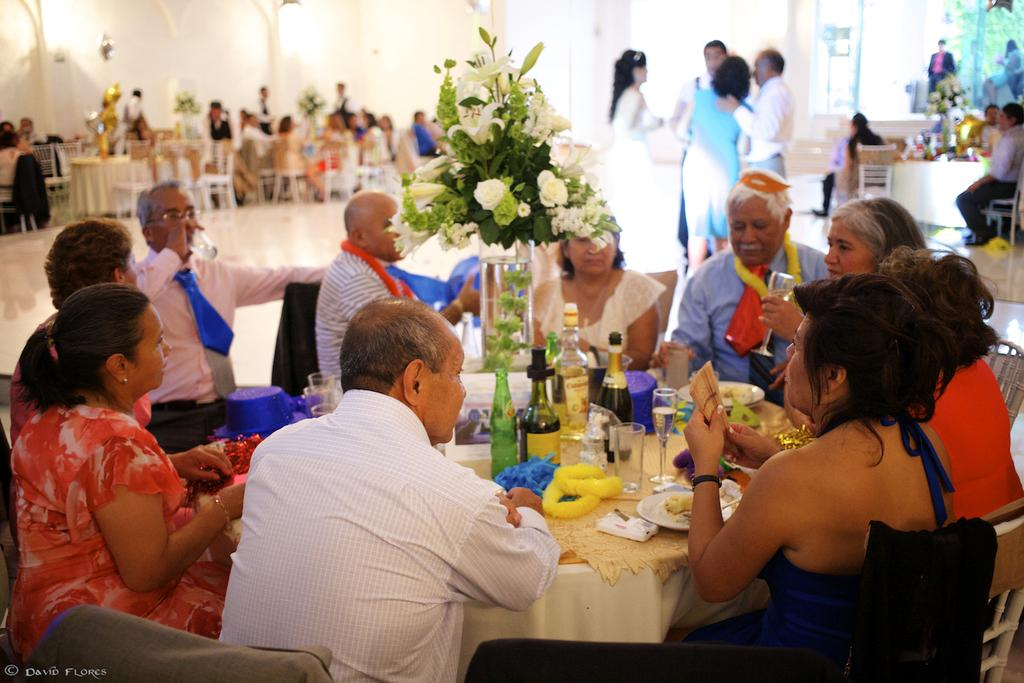What are the people in the image doing? There is a group of people sitting on chairs in the image. What objects can be seen on the table in the image? There is a bottle, a plate, a glass, food, a spoon, and a flower pot on the table in the image. What is the texture of the planes in the image? There are no planes present in the image, so it is not possible to determine their texture. 